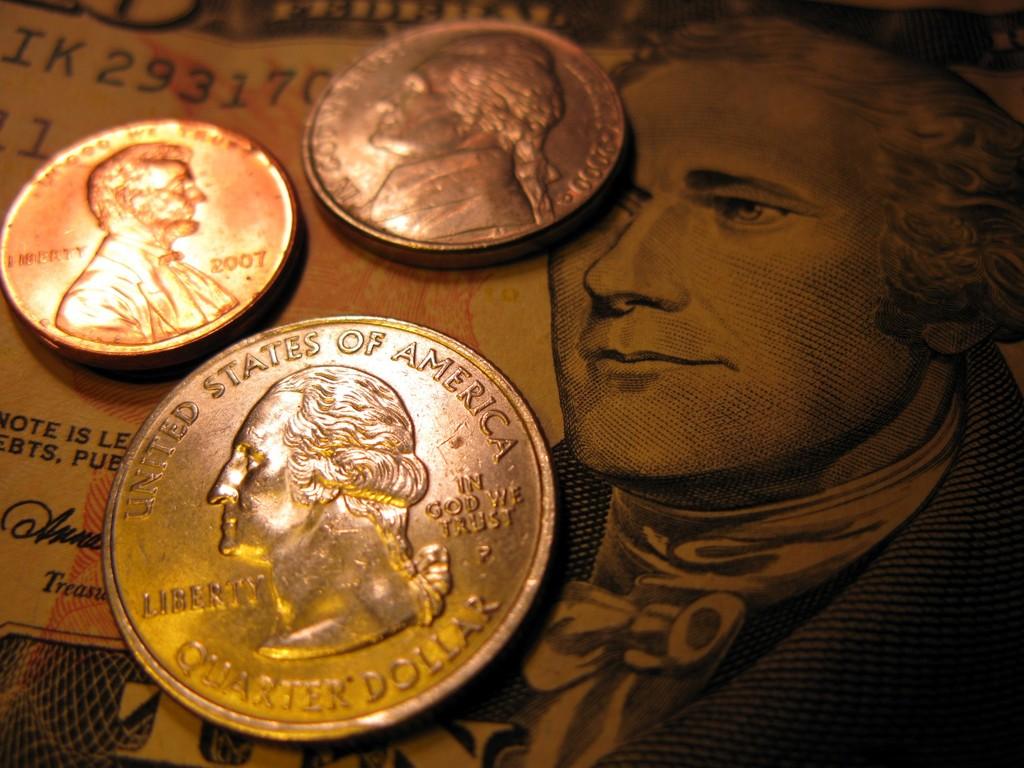What country is the coin from?
Your answer should be compact. United states of america. What is the type of coin?
Keep it short and to the point. Quarter dollar. 